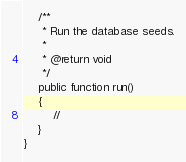<code> <loc_0><loc_0><loc_500><loc_500><_PHP_>    /**
     * Run the database seeds.
     *
     * @return void
     */
    public function run()
    {
        //
    }
}
</code> 